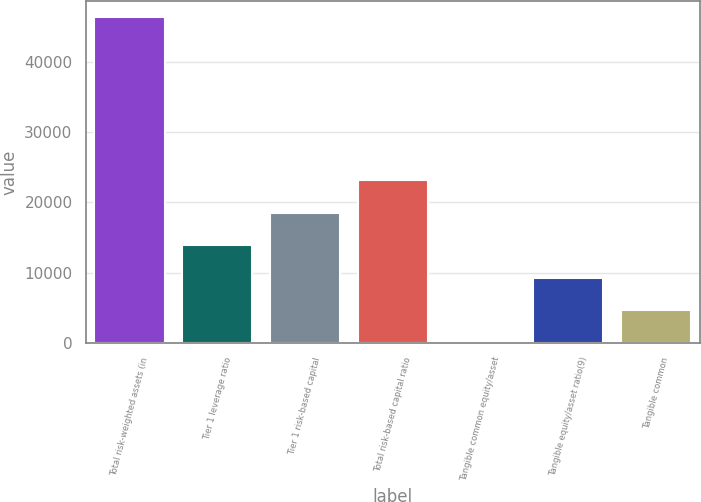<chart> <loc_0><loc_0><loc_500><loc_500><bar_chart><fcel>Total risk-weighted assets (in<fcel>Tier 1 leverage ratio<fcel>Tier 1 risk-based capital<fcel>Total risk-based capital ratio<fcel>Tangible common equity/asset<fcel>Tangible equity/asset ratio(9)<fcel>Tangible common<nl><fcel>46383<fcel>13918.1<fcel>18556<fcel>23193.8<fcel>4.65<fcel>9280.31<fcel>4642.48<nl></chart> 